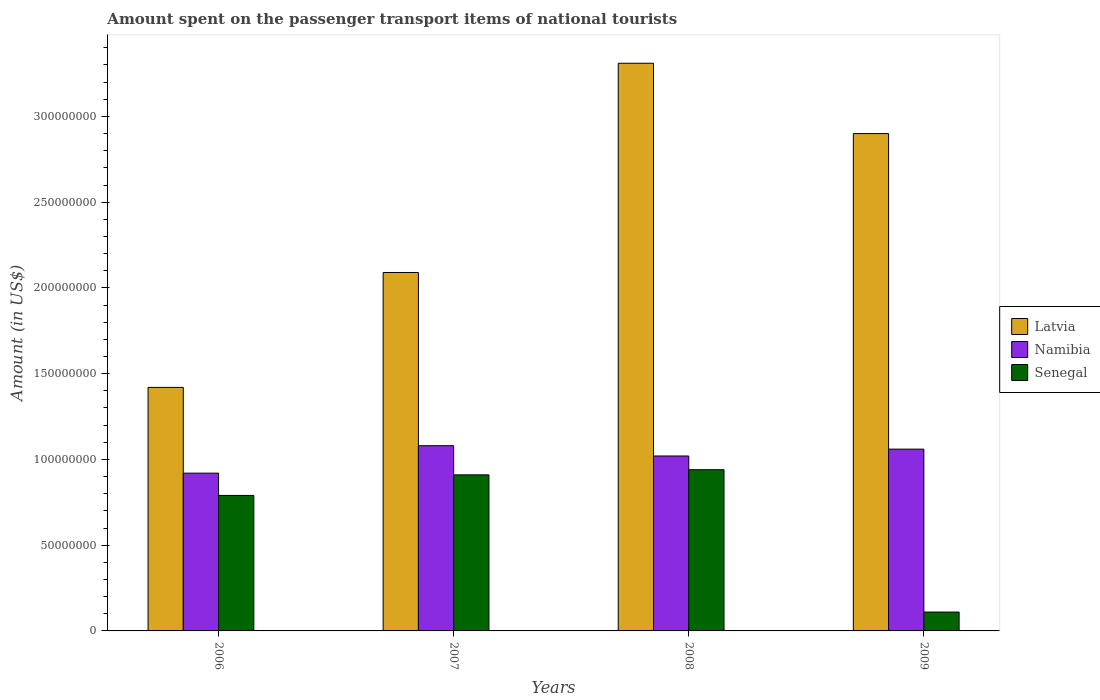How many different coloured bars are there?
Offer a terse response. 3. Are the number of bars per tick equal to the number of legend labels?
Your response must be concise. Yes. What is the label of the 1st group of bars from the left?
Keep it short and to the point. 2006. What is the amount spent on the passenger transport items of national tourists in Senegal in 2006?
Ensure brevity in your answer.  7.90e+07. Across all years, what is the maximum amount spent on the passenger transport items of national tourists in Latvia?
Your answer should be very brief. 3.31e+08. Across all years, what is the minimum amount spent on the passenger transport items of national tourists in Namibia?
Offer a terse response. 9.20e+07. In which year was the amount spent on the passenger transport items of national tourists in Senegal maximum?
Make the answer very short. 2008. What is the total amount spent on the passenger transport items of national tourists in Senegal in the graph?
Ensure brevity in your answer.  2.75e+08. What is the difference between the amount spent on the passenger transport items of national tourists in Senegal in 2007 and that in 2009?
Make the answer very short. 8.00e+07. What is the difference between the amount spent on the passenger transport items of national tourists in Senegal in 2008 and the amount spent on the passenger transport items of national tourists in Namibia in 2007?
Offer a very short reply. -1.40e+07. What is the average amount spent on the passenger transport items of national tourists in Latvia per year?
Ensure brevity in your answer.  2.43e+08. In the year 2007, what is the difference between the amount spent on the passenger transport items of national tourists in Senegal and amount spent on the passenger transport items of national tourists in Latvia?
Keep it short and to the point. -1.18e+08. In how many years, is the amount spent on the passenger transport items of national tourists in Namibia greater than 80000000 US$?
Your answer should be compact. 4. What is the ratio of the amount spent on the passenger transport items of national tourists in Senegal in 2007 to that in 2009?
Your answer should be very brief. 8.27. Is the amount spent on the passenger transport items of national tourists in Latvia in 2006 less than that in 2009?
Your response must be concise. Yes. Is the difference between the amount spent on the passenger transport items of national tourists in Senegal in 2007 and 2008 greater than the difference between the amount spent on the passenger transport items of national tourists in Latvia in 2007 and 2008?
Make the answer very short. Yes. What is the difference between the highest and the second highest amount spent on the passenger transport items of national tourists in Senegal?
Provide a succinct answer. 3.00e+06. What is the difference between the highest and the lowest amount spent on the passenger transport items of national tourists in Namibia?
Your answer should be compact. 1.60e+07. What does the 3rd bar from the left in 2009 represents?
Ensure brevity in your answer.  Senegal. What does the 2nd bar from the right in 2006 represents?
Offer a very short reply. Namibia. Is it the case that in every year, the sum of the amount spent on the passenger transport items of national tourists in Namibia and amount spent on the passenger transport items of national tourists in Senegal is greater than the amount spent on the passenger transport items of national tourists in Latvia?
Your response must be concise. No. How many years are there in the graph?
Ensure brevity in your answer.  4. Are the values on the major ticks of Y-axis written in scientific E-notation?
Ensure brevity in your answer.  No. Does the graph contain any zero values?
Provide a short and direct response. No. How many legend labels are there?
Keep it short and to the point. 3. What is the title of the graph?
Offer a very short reply. Amount spent on the passenger transport items of national tourists. Does "Malawi" appear as one of the legend labels in the graph?
Your answer should be compact. No. What is the label or title of the X-axis?
Provide a succinct answer. Years. What is the Amount (in US$) in Latvia in 2006?
Offer a terse response. 1.42e+08. What is the Amount (in US$) of Namibia in 2006?
Give a very brief answer. 9.20e+07. What is the Amount (in US$) in Senegal in 2006?
Offer a very short reply. 7.90e+07. What is the Amount (in US$) of Latvia in 2007?
Offer a very short reply. 2.09e+08. What is the Amount (in US$) of Namibia in 2007?
Give a very brief answer. 1.08e+08. What is the Amount (in US$) of Senegal in 2007?
Your answer should be compact. 9.10e+07. What is the Amount (in US$) of Latvia in 2008?
Offer a terse response. 3.31e+08. What is the Amount (in US$) of Namibia in 2008?
Your answer should be compact. 1.02e+08. What is the Amount (in US$) of Senegal in 2008?
Your answer should be very brief. 9.40e+07. What is the Amount (in US$) in Latvia in 2009?
Ensure brevity in your answer.  2.90e+08. What is the Amount (in US$) in Namibia in 2009?
Offer a terse response. 1.06e+08. What is the Amount (in US$) of Senegal in 2009?
Offer a terse response. 1.10e+07. Across all years, what is the maximum Amount (in US$) in Latvia?
Offer a very short reply. 3.31e+08. Across all years, what is the maximum Amount (in US$) in Namibia?
Provide a succinct answer. 1.08e+08. Across all years, what is the maximum Amount (in US$) in Senegal?
Provide a succinct answer. 9.40e+07. Across all years, what is the minimum Amount (in US$) of Latvia?
Offer a terse response. 1.42e+08. Across all years, what is the minimum Amount (in US$) in Namibia?
Give a very brief answer. 9.20e+07. Across all years, what is the minimum Amount (in US$) in Senegal?
Keep it short and to the point. 1.10e+07. What is the total Amount (in US$) of Latvia in the graph?
Ensure brevity in your answer.  9.72e+08. What is the total Amount (in US$) in Namibia in the graph?
Ensure brevity in your answer.  4.08e+08. What is the total Amount (in US$) in Senegal in the graph?
Offer a terse response. 2.75e+08. What is the difference between the Amount (in US$) of Latvia in 2006 and that in 2007?
Ensure brevity in your answer.  -6.70e+07. What is the difference between the Amount (in US$) of Namibia in 2006 and that in 2007?
Offer a very short reply. -1.60e+07. What is the difference between the Amount (in US$) in Senegal in 2006 and that in 2007?
Your answer should be very brief. -1.20e+07. What is the difference between the Amount (in US$) in Latvia in 2006 and that in 2008?
Ensure brevity in your answer.  -1.89e+08. What is the difference between the Amount (in US$) in Namibia in 2006 and that in 2008?
Your answer should be very brief. -1.00e+07. What is the difference between the Amount (in US$) in Senegal in 2006 and that in 2008?
Your response must be concise. -1.50e+07. What is the difference between the Amount (in US$) in Latvia in 2006 and that in 2009?
Your answer should be very brief. -1.48e+08. What is the difference between the Amount (in US$) of Namibia in 2006 and that in 2009?
Your answer should be compact. -1.40e+07. What is the difference between the Amount (in US$) of Senegal in 2006 and that in 2009?
Ensure brevity in your answer.  6.80e+07. What is the difference between the Amount (in US$) of Latvia in 2007 and that in 2008?
Provide a succinct answer. -1.22e+08. What is the difference between the Amount (in US$) in Latvia in 2007 and that in 2009?
Ensure brevity in your answer.  -8.10e+07. What is the difference between the Amount (in US$) in Namibia in 2007 and that in 2009?
Keep it short and to the point. 2.00e+06. What is the difference between the Amount (in US$) of Senegal in 2007 and that in 2009?
Ensure brevity in your answer.  8.00e+07. What is the difference between the Amount (in US$) of Latvia in 2008 and that in 2009?
Your answer should be compact. 4.10e+07. What is the difference between the Amount (in US$) in Namibia in 2008 and that in 2009?
Offer a terse response. -4.00e+06. What is the difference between the Amount (in US$) of Senegal in 2008 and that in 2009?
Provide a succinct answer. 8.30e+07. What is the difference between the Amount (in US$) in Latvia in 2006 and the Amount (in US$) in Namibia in 2007?
Keep it short and to the point. 3.40e+07. What is the difference between the Amount (in US$) of Latvia in 2006 and the Amount (in US$) of Senegal in 2007?
Offer a very short reply. 5.10e+07. What is the difference between the Amount (in US$) in Namibia in 2006 and the Amount (in US$) in Senegal in 2007?
Provide a succinct answer. 1.00e+06. What is the difference between the Amount (in US$) of Latvia in 2006 and the Amount (in US$) of Namibia in 2008?
Your answer should be very brief. 4.00e+07. What is the difference between the Amount (in US$) of Latvia in 2006 and the Amount (in US$) of Senegal in 2008?
Make the answer very short. 4.80e+07. What is the difference between the Amount (in US$) of Namibia in 2006 and the Amount (in US$) of Senegal in 2008?
Your answer should be compact. -2.00e+06. What is the difference between the Amount (in US$) of Latvia in 2006 and the Amount (in US$) of Namibia in 2009?
Your answer should be compact. 3.60e+07. What is the difference between the Amount (in US$) of Latvia in 2006 and the Amount (in US$) of Senegal in 2009?
Keep it short and to the point. 1.31e+08. What is the difference between the Amount (in US$) in Namibia in 2006 and the Amount (in US$) in Senegal in 2009?
Your answer should be very brief. 8.10e+07. What is the difference between the Amount (in US$) of Latvia in 2007 and the Amount (in US$) of Namibia in 2008?
Give a very brief answer. 1.07e+08. What is the difference between the Amount (in US$) of Latvia in 2007 and the Amount (in US$) of Senegal in 2008?
Provide a succinct answer. 1.15e+08. What is the difference between the Amount (in US$) of Namibia in 2007 and the Amount (in US$) of Senegal in 2008?
Provide a short and direct response. 1.40e+07. What is the difference between the Amount (in US$) of Latvia in 2007 and the Amount (in US$) of Namibia in 2009?
Ensure brevity in your answer.  1.03e+08. What is the difference between the Amount (in US$) in Latvia in 2007 and the Amount (in US$) in Senegal in 2009?
Provide a succinct answer. 1.98e+08. What is the difference between the Amount (in US$) in Namibia in 2007 and the Amount (in US$) in Senegal in 2009?
Make the answer very short. 9.70e+07. What is the difference between the Amount (in US$) of Latvia in 2008 and the Amount (in US$) of Namibia in 2009?
Your answer should be compact. 2.25e+08. What is the difference between the Amount (in US$) of Latvia in 2008 and the Amount (in US$) of Senegal in 2009?
Your answer should be compact. 3.20e+08. What is the difference between the Amount (in US$) in Namibia in 2008 and the Amount (in US$) in Senegal in 2009?
Your answer should be compact. 9.10e+07. What is the average Amount (in US$) of Latvia per year?
Keep it short and to the point. 2.43e+08. What is the average Amount (in US$) of Namibia per year?
Make the answer very short. 1.02e+08. What is the average Amount (in US$) of Senegal per year?
Offer a terse response. 6.88e+07. In the year 2006, what is the difference between the Amount (in US$) in Latvia and Amount (in US$) in Namibia?
Provide a succinct answer. 5.00e+07. In the year 2006, what is the difference between the Amount (in US$) of Latvia and Amount (in US$) of Senegal?
Offer a very short reply. 6.30e+07. In the year 2006, what is the difference between the Amount (in US$) of Namibia and Amount (in US$) of Senegal?
Provide a succinct answer. 1.30e+07. In the year 2007, what is the difference between the Amount (in US$) in Latvia and Amount (in US$) in Namibia?
Provide a succinct answer. 1.01e+08. In the year 2007, what is the difference between the Amount (in US$) in Latvia and Amount (in US$) in Senegal?
Offer a terse response. 1.18e+08. In the year 2007, what is the difference between the Amount (in US$) of Namibia and Amount (in US$) of Senegal?
Give a very brief answer. 1.70e+07. In the year 2008, what is the difference between the Amount (in US$) in Latvia and Amount (in US$) in Namibia?
Your answer should be compact. 2.29e+08. In the year 2008, what is the difference between the Amount (in US$) of Latvia and Amount (in US$) of Senegal?
Give a very brief answer. 2.37e+08. In the year 2009, what is the difference between the Amount (in US$) in Latvia and Amount (in US$) in Namibia?
Offer a very short reply. 1.84e+08. In the year 2009, what is the difference between the Amount (in US$) of Latvia and Amount (in US$) of Senegal?
Provide a succinct answer. 2.79e+08. In the year 2009, what is the difference between the Amount (in US$) in Namibia and Amount (in US$) in Senegal?
Make the answer very short. 9.50e+07. What is the ratio of the Amount (in US$) of Latvia in 2006 to that in 2007?
Your answer should be compact. 0.68. What is the ratio of the Amount (in US$) in Namibia in 2006 to that in 2007?
Your answer should be very brief. 0.85. What is the ratio of the Amount (in US$) of Senegal in 2006 to that in 2007?
Keep it short and to the point. 0.87. What is the ratio of the Amount (in US$) in Latvia in 2006 to that in 2008?
Keep it short and to the point. 0.43. What is the ratio of the Amount (in US$) of Namibia in 2006 to that in 2008?
Offer a terse response. 0.9. What is the ratio of the Amount (in US$) in Senegal in 2006 to that in 2008?
Offer a very short reply. 0.84. What is the ratio of the Amount (in US$) of Latvia in 2006 to that in 2009?
Give a very brief answer. 0.49. What is the ratio of the Amount (in US$) in Namibia in 2006 to that in 2009?
Provide a succinct answer. 0.87. What is the ratio of the Amount (in US$) of Senegal in 2006 to that in 2009?
Provide a short and direct response. 7.18. What is the ratio of the Amount (in US$) of Latvia in 2007 to that in 2008?
Keep it short and to the point. 0.63. What is the ratio of the Amount (in US$) in Namibia in 2007 to that in 2008?
Provide a succinct answer. 1.06. What is the ratio of the Amount (in US$) of Senegal in 2007 to that in 2008?
Ensure brevity in your answer.  0.97. What is the ratio of the Amount (in US$) of Latvia in 2007 to that in 2009?
Offer a terse response. 0.72. What is the ratio of the Amount (in US$) of Namibia in 2007 to that in 2009?
Your answer should be very brief. 1.02. What is the ratio of the Amount (in US$) in Senegal in 2007 to that in 2009?
Provide a succinct answer. 8.27. What is the ratio of the Amount (in US$) of Latvia in 2008 to that in 2009?
Offer a terse response. 1.14. What is the ratio of the Amount (in US$) of Namibia in 2008 to that in 2009?
Your answer should be very brief. 0.96. What is the ratio of the Amount (in US$) in Senegal in 2008 to that in 2009?
Keep it short and to the point. 8.55. What is the difference between the highest and the second highest Amount (in US$) in Latvia?
Your answer should be very brief. 4.10e+07. What is the difference between the highest and the lowest Amount (in US$) in Latvia?
Ensure brevity in your answer.  1.89e+08. What is the difference between the highest and the lowest Amount (in US$) in Namibia?
Your answer should be very brief. 1.60e+07. What is the difference between the highest and the lowest Amount (in US$) in Senegal?
Keep it short and to the point. 8.30e+07. 